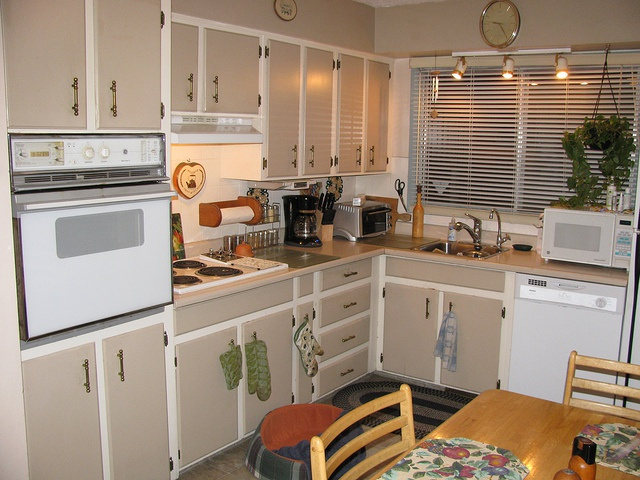Describe the objects in this image and their specific colors. I can see oven in gray, lightgray, darkgray, and black tones, refrigerator in gray, lightgray, and darkgray tones, dining table in gray, olive, tan, and orange tones, chair in gray, tan, black, and olive tones, and microwave in gray, darkgray, lightgray, and black tones in this image. 